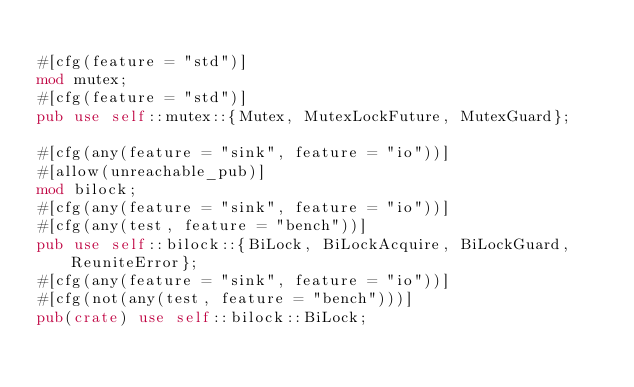Convert code to text. <code><loc_0><loc_0><loc_500><loc_500><_Rust_>
#[cfg(feature = "std")]
mod mutex;
#[cfg(feature = "std")]
pub use self::mutex::{Mutex, MutexLockFuture, MutexGuard};

#[cfg(any(feature = "sink", feature = "io"))]
#[allow(unreachable_pub)]
mod bilock;
#[cfg(any(feature = "sink", feature = "io"))]
#[cfg(any(test, feature = "bench"))]
pub use self::bilock::{BiLock, BiLockAcquire, BiLockGuard, ReuniteError};
#[cfg(any(feature = "sink", feature = "io"))]
#[cfg(not(any(test, feature = "bench")))]
pub(crate) use self::bilock::BiLock;
</code> 